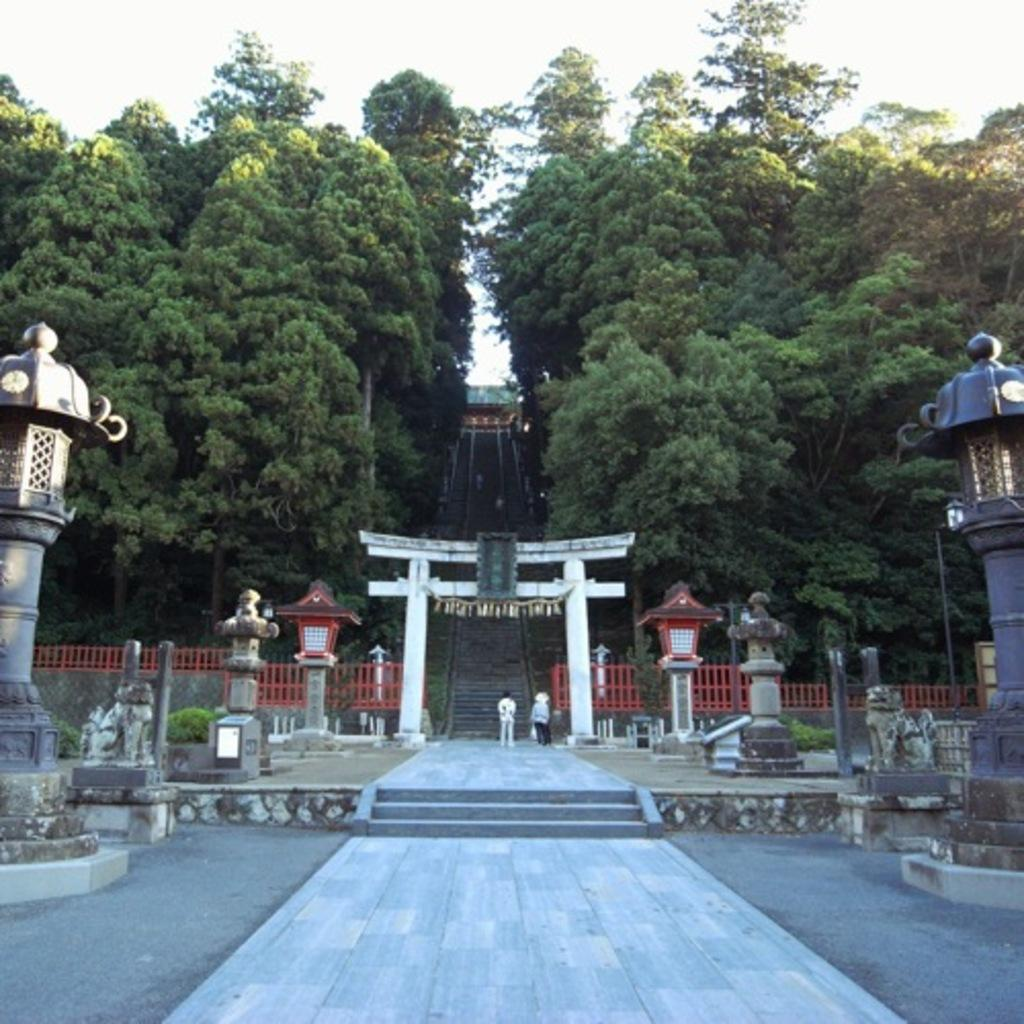Who can be seen in the image? There are rich people in the image. What architectural feature is present in the image? There are stairs in the image. What type of vegetation is visible in the image? There are trees and plants in the image. What structural elements can be seen in the image? There are pillars in the image. What can be seen in the background of the image? The sky is visible in the background of the image. What type of rings are being exchanged between family members in the image? There is no family or ring exchange present in the image; it features rich people and other elements mentioned in the facts. 